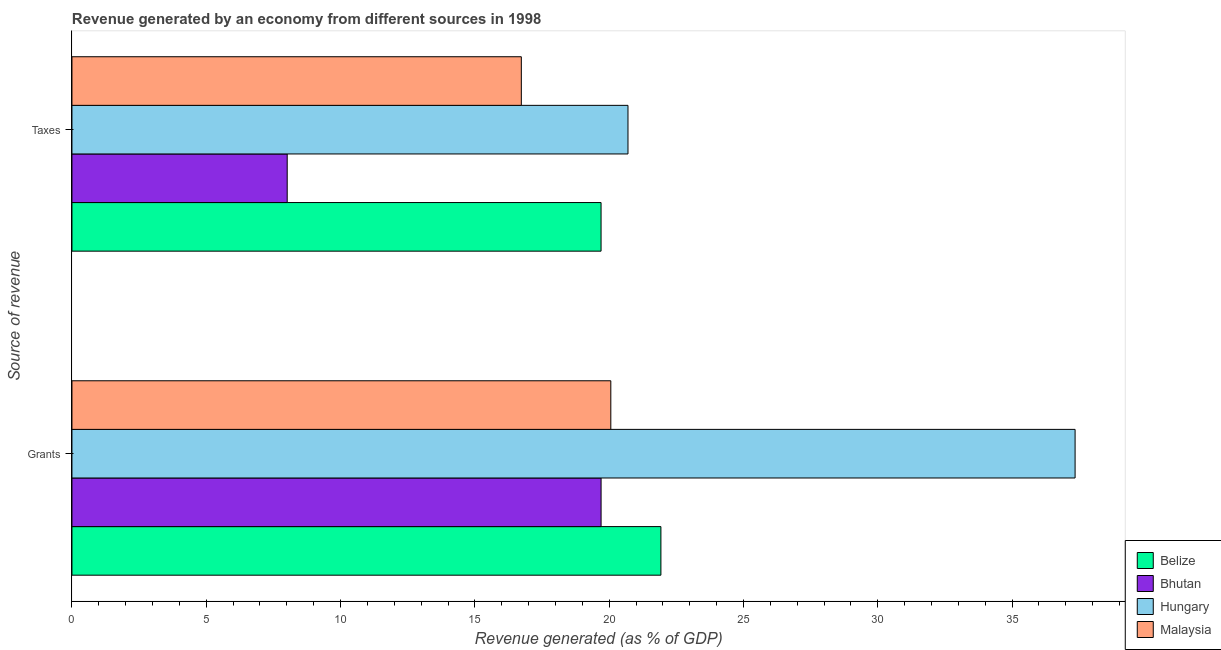How many different coloured bars are there?
Ensure brevity in your answer.  4. How many bars are there on the 2nd tick from the top?
Provide a succinct answer. 4. How many bars are there on the 1st tick from the bottom?
Ensure brevity in your answer.  4. What is the label of the 1st group of bars from the top?
Keep it short and to the point. Taxes. What is the revenue generated by taxes in Hungary?
Offer a terse response. 20.7. Across all countries, what is the maximum revenue generated by taxes?
Provide a succinct answer. 20.7. Across all countries, what is the minimum revenue generated by grants?
Your response must be concise. 19.7. In which country was the revenue generated by taxes maximum?
Your response must be concise. Hungary. In which country was the revenue generated by taxes minimum?
Your answer should be very brief. Bhutan. What is the total revenue generated by taxes in the graph?
Provide a succinct answer. 65.14. What is the difference between the revenue generated by grants in Belize and that in Malaysia?
Offer a very short reply. 1.86. What is the difference between the revenue generated by grants in Bhutan and the revenue generated by taxes in Belize?
Offer a terse response. 0. What is the average revenue generated by grants per country?
Make the answer very short. 24.76. What is the difference between the revenue generated by taxes and revenue generated by grants in Belize?
Your answer should be compact. -2.23. In how many countries, is the revenue generated by taxes greater than 3 %?
Make the answer very short. 4. What is the ratio of the revenue generated by taxes in Belize to that in Hungary?
Offer a very short reply. 0.95. What does the 1st bar from the top in Taxes represents?
Provide a short and direct response. Malaysia. What does the 1st bar from the bottom in Taxes represents?
Offer a very short reply. Belize. How many bars are there?
Ensure brevity in your answer.  8. Are all the bars in the graph horizontal?
Give a very brief answer. Yes. How many countries are there in the graph?
Your response must be concise. 4. What is the difference between two consecutive major ticks on the X-axis?
Provide a short and direct response. 5. Are the values on the major ticks of X-axis written in scientific E-notation?
Give a very brief answer. No. Does the graph contain any zero values?
Provide a short and direct response. No. Does the graph contain grids?
Provide a succinct answer. No. Where does the legend appear in the graph?
Offer a very short reply. Bottom right. What is the title of the graph?
Your answer should be compact. Revenue generated by an economy from different sources in 1998. What is the label or title of the X-axis?
Ensure brevity in your answer.  Revenue generated (as % of GDP). What is the label or title of the Y-axis?
Provide a short and direct response. Source of revenue. What is the Revenue generated (as % of GDP) of Belize in Grants?
Ensure brevity in your answer.  21.93. What is the Revenue generated (as % of GDP) of Bhutan in Grants?
Your response must be concise. 19.7. What is the Revenue generated (as % of GDP) of Hungary in Grants?
Make the answer very short. 37.35. What is the Revenue generated (as % of GDP) in Malaysia in Grants?
Your response must be concise. 20.06. What is the Revenue generated (as % of GDP) in Belize in Taxes?
Your response must be concise. 19.7. What is the Revenue generated (as % of GDP) in Bhutan in Taxes?
Provide a succinct answer. 8.01. What is the Revenue generated (as % of GDP) of Hungary in Taxes?
Offer a terse response. 20.7. What is the Revenue generated (as % of GDP) in Malaysia in Taxes?
Make the answer very short. 16.73. Across all Source of revenue, what is the maximum Revenue generated (as % of GDP) of Belize?
Provide a short and direct response. 21.93. Across all Source of revenue, what is the maximum Revenue generated (as % of GDP) in Bhutan?
Your answer should be very brief. 19.7. Across all Source of revenue, what is the maximum Revenue generated (as % of GDP) in Hungary?
Your response must be concise. 37.35. Across all Source of revenue, what is the maximum Revenue generated (as % of GDP) in Malaysia?
Provide a short and direct response. 20.06. Across all Source of revenue, what is the minimum Revenue generated (as % of GDP) of Belize?
Your answer should be compact. 19.7. Across all Source of revenue, what is the minimum Revenue generated (as % of GDP) of Bhutan?
Your answer should be compact. 8.01. Across all Source of revenue, what is the minimum Revenue generated (as % of GDP) of Hungary?
Give a very brief answer. 20.7. Across all Source of revenue, what is the minimum Revenue generated (as % of GDP) in Malaysia?
Keep it short and to the point. 16.73. What is the total Revenue generated (as % of GDP) of Belize in the graph?
Offer a terse response. 41.62. What is the total Revenue generated (as % of GDP) of Bhutan in the graph?
Your answer should be very brief. 27.71. What is the total Revenue generated (as % of GDP) in Hungary in the graph?
Offer a terse response. 58.05. What is the total Revenue generated (as % of GDP) of Malaysia in the graph?
Offer a terse response. 36.79. What is the difference between the Revenue generated (as % of GDP) of Belize in Grants and that in Taxes?
Your answer should be very brief. 2.23. What is the difference between the Revenue generated (as % of GDP) of Bhutan in Grants and that in Taxes?
Your answer should be compact. 11.69. What is the difference between the Revenue generated (as % of GDP) of Hungary in Grants and that in Taxes?
Provide a succinct answer. 16.65. What is the difference between the Revenue generated (as % of GDP) of Malaysia in Grants and that in Taxes?
Ensure brevity in your answer.  3.33. What is the difference between the Revenue generated (as % of GDP) in Belize in Grants and the Revenue generated (as % of GDP) in Bhutan in Taxes?
Offer a very short reply. 13.91. What is the difference between the Revenue generated (as % of GDP) of Belize in Grants and the Revenue generated (as % of GDP) of Hungary in Taxes?
Provide a short and direct response. 1.23. What is the difference between the Revenue generated (as % of GDP) in Belize in Grants and the Revenue generated (as % of GDP) in Malaysia in Taxes?
Provide a short and direct response. 5.2. What is the difference between the Revenue generated (as % of GDP) of Bhutan in Grants and the Revenue generated (as % of GDP) of Hungary in Taxes?
Provide a short and direct response. -1. What is the difference between the Revenue generated (as % of GDP) of Bhutan in Grants and the Revenue generated (as % of GDP) of Malaysia in Taxes?
Your response must be concise. 2.97. What is the difference between the Revenue generated (as % of GDP) of Hungary in Grants and the Revenue generated (as % of GDP) of Malaysia in Taxes?
Keep it short and to the point. 20.62. What is the average Revenue generated (as % of GDP) of Belize per Source of revenue?
Make the answer very short. 20.81. What is the average Revenue generated (as % of GDP) of Bhutan per Source of revenue?
Your answer should be very brief. 13.86. What is the average Revenue generated (as % of GDP) in Hungary per Source of revenue?
Your answer should be very brief. 29.02. What is the average Revenue generated (as % of GDP) in Malaysia per Source of revenue?
Provide a succinct answer. 18.4. What is the difference between the Revenue generated (as % of GDP) in Belize and Revenue generated (as % of GDP) in Bhutan in Grants?
Keep it short and to the point. 2.23. What is the difference between the Revenue generated (as % of GDP) of Belize and Revenue generated (as % of GDP) of Hungary in Grants?
Your answer should be compact. -15.42. What is the difference between the Revenue generated (as % of GDP) in Belize and Revenue generated (as % of GDP) in Malaysia in Grants?
Offer a terse response. 1.86. What is the difference between the Revenue generated (as % of GDP) in Bhutan and Revenue generated (as % of GDP) in Hungary in Grants?
Make the answer very short. -17.65. What is the difference between the Revenue generated (as % of GDP) in Bhutan and Revenue generated (as % of GDP) in Malaysia in Grants?
Keep it short and to the point. -0.36. What is the difference between the Revenue generated (as % of GDP) of Hungary and Revenue generated (as % of GDP) of Malaysia in Grants?
Your response must be concise. 17.29. What is the difference between the Revenue generated (as % of GDP) in Belize and Revenue generated (as % of GDP) in Bhutan in Taxes?
Your response must be concise. 11.68. What is the difference between the Revenue generated (as % of GDP) of Belize and Revenue generated (as % of GDP) of Hungary in Taxes?
Provide a succinct answer. -1. What is the difference between the Revenue generated (as % of GDP) in Belize and Revenue generated (as % of GDP) in Malaysia in Taxes?
Your response must be concise. 2.97. What is the difference between the Revenue generated (as % of GDP) of Bhutan and Revenue generated (as % of GDP) of Hungary in Taxes?
Ensure brevity in your answer.  -12.69. What is the difference between the Revenue generated (as % of GDP) in Bhutan and Revenue generated (as % of GDP) in Malaysia in Taxes?
Give a very brief answer. -8.72. What is the difference between the Revenue generated (as % of GDP) of Hungary and Revenue generated (as % of GDP) of Malaysia in Taxes?
Make the answer very short. 3.97. What is the ratio of the Revenue generated (as % of GDP) of Belize in Grants to that in Taxes?
Your answer should be very brief. 1.11. What is the ratio of the Revenue generated (as % of GDP) of Bhutan in Grants to that in Taxes?
Provide a succinct answer. 2.46. What is the ratio of the Revenue generated (as % of GDP) of Hungary in Grants to that in Taxes?
Provide a succinct answer. 1.8. What is the ratio of the Revenue generated (as % of GDP) of Malaysia in Grants to that in Taxes?
Provide a short and direct response. 1.2. What is the difference between the highest and the second highest Revenue generated (as % of GDP) in Belize?
Make the answer very short. 2.23. What is the difference between the highest and the second highest Revenue generated (as % of GDP) in Bhutan?
Offer a very short reply. 11.69. What is the difference between the highest and the second highest Revenue generated (as % of GDP) in Hungary?
Provide a succinct answer. 16.65. What is the difference between the highest and the second highest Revenue generated (as % of GDP) of Malaysia?
Your response must be concise. 3.33. What is the difference between the highest and the lowest Revenue generated (as % of GDP) in Belize?
Make the answer very short. 2.23. What is the difference between the highest and the lowest Revenue generated (as % of GDP) of Bhutan?
Provide a succinct answer. 11.69. What is the difference between the highest and the lowest Revenue generated (as % of GDP) in Hungary?
Keep it short and to the point. 16.65. What is the difference between the highest and the lowest Revenue generated (as % of GDP) of Malaysia?
Your answer should be very brief. 3.33. 